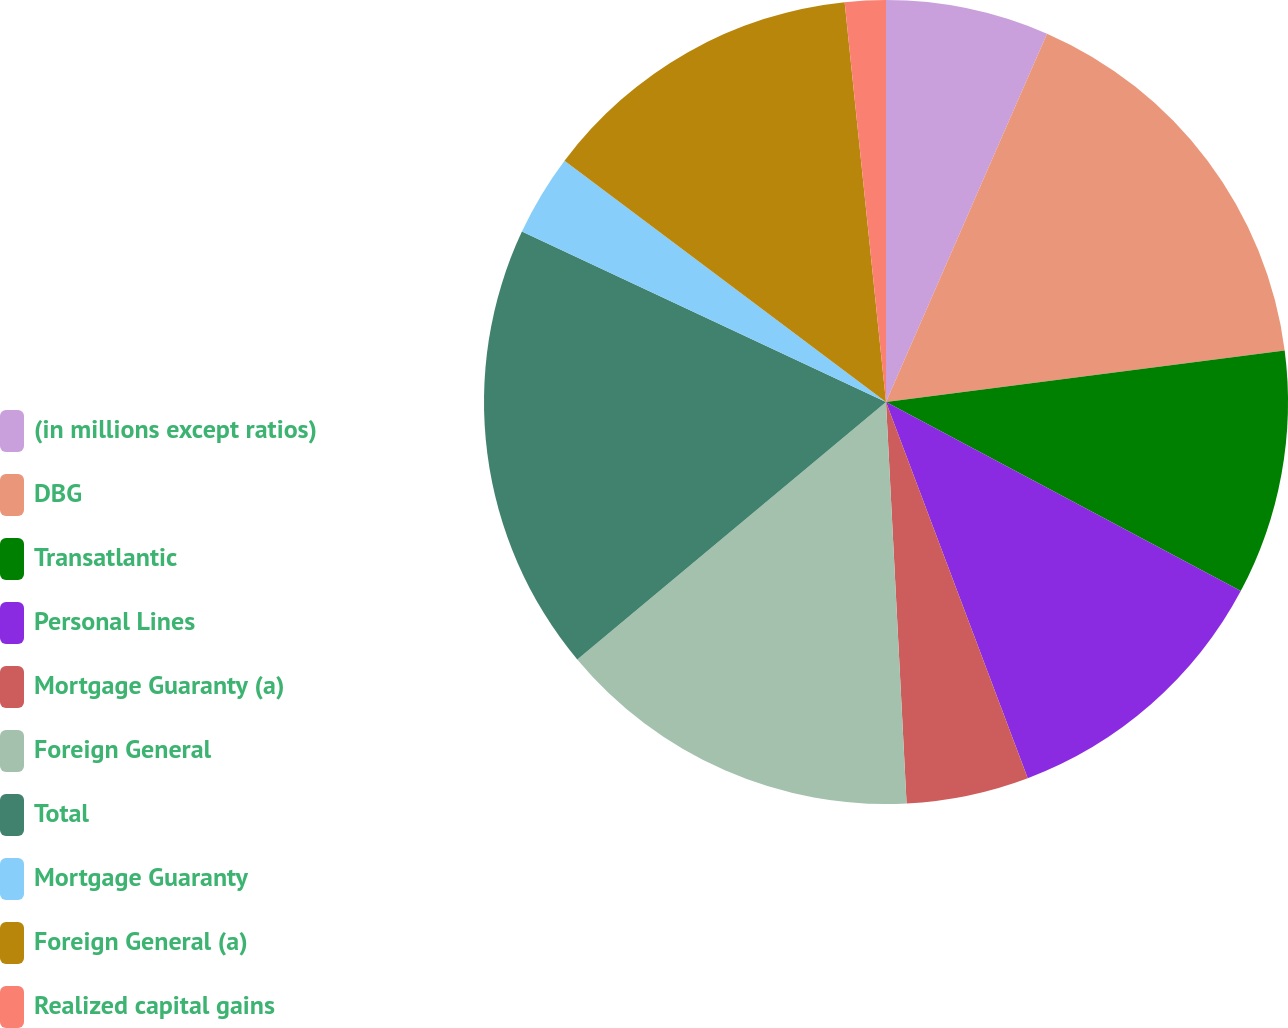Convert chart to OTSL. <chart><loc_0><loc_0><loc_500><loc_500><pie_chart><fcel>(in millions except ratios)<fcel>DBG<fcel>Transatlantic<fcel>Personal Lines<fcel>Mortgage Guaranty (a)<fcel>Foreign General<fcel>Total<fcel>Mortgage Guaranty<fcel>Foreign General (a)<fcel>Realized capital gains<nl><fcel>6.56%<fcel>16.39%<fcel>9.84%<fcel>11.47%<fcel>4.92%<fcel>14.75%<fcel>18.03%<fcel>3.28%<fcel>13.11%<fcel>1.64%<nl></chart> 